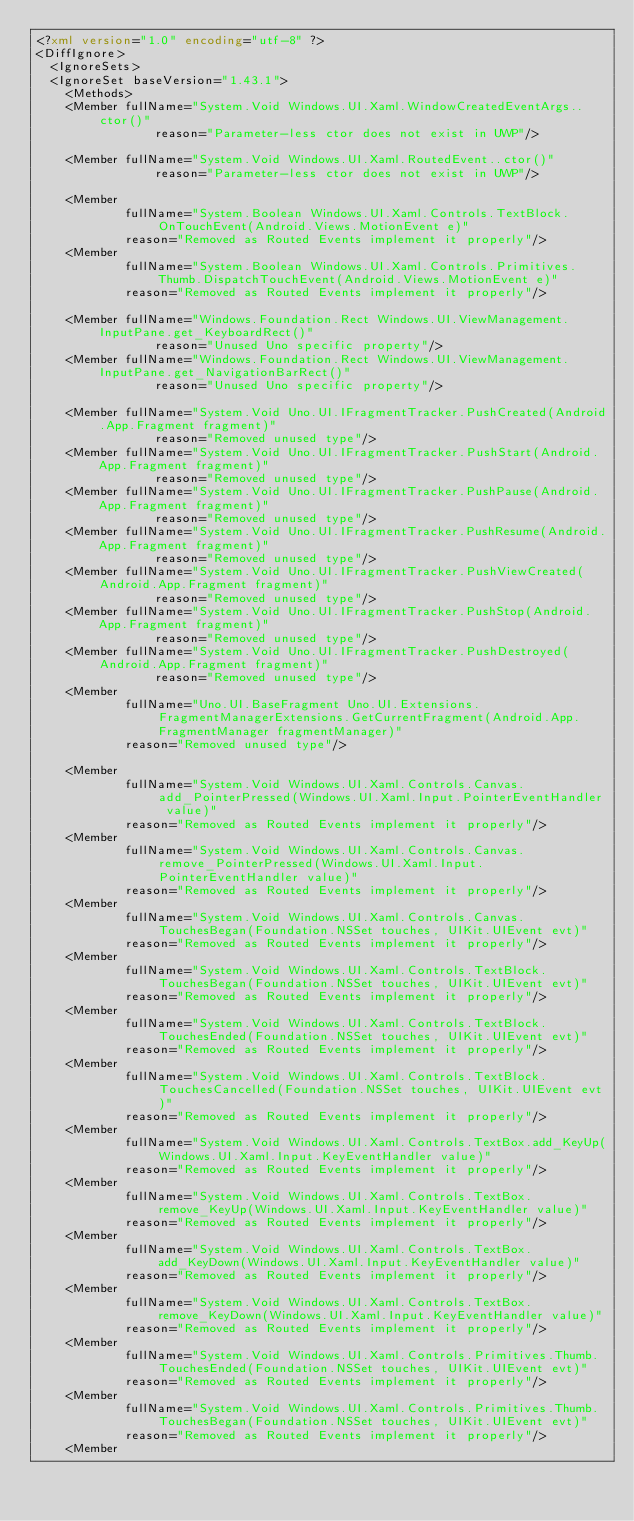<code> <loc_0><loc_0><loc_500><loc_500><_XML_><?xml version="1.0" encoding="utf-8" ?>
<DiffIgnore>
  <IgnoreSets>
	<IgnoreSet baseVersion="1.43.1">
	  <Methods>
		<Member fullName="System.Void Windows.UI.Xaml.WindowCreatedEventArgs..ctor()"
                reason="Parameter-less ctor does not exist in UWP"/>

		<Member fullName="System.Void Windows.UI.Xaml.RoutedEvent..ctor()"
                reason="Parameter-less ctor does not exist in UWP"/>

		<Member
            fullName="System.Boolean Windows.UI.Xaml.Controls.TextBlock.OnTouchEvent(Android.Views.MotionEvent e)"
            reason="Removed as Routed Events implement it properly"/>
		<Member
            fullName="System.Boolean Windows.UI.Xaml.Controls.Primitives.Thumb.DispatchTouchEvent(Android.Views.MotionEvent e)"
            reason="Removed as Routed Events implement it properly"/>

		<Member fullName="Windows.Foundation.Rect Windows.UI.ViewManagement.InputPane.get_KeyboardRect()"
                reason="Unused Uno specific property"/>
		<Member fullName="Windows.Foundation.Rect Windows.UI.ViewManagement.InputPane.get_NavigationBarRect()"
                reason="Unused Uno specific property"/>

		<Member fullName="System.Void Uno.UI.IFragmentTracker.PushCreated(Android.App.Fragment fragment)"
                reason="Removed unused type"/>
		<Member fullName="System.Void Uno.UI.IFragmentTracker.PushStart(Android.App.Fragment fragment)"
                reason="Removed unused type"/>
		<Member fullName="System.Void Uno.UI.IFragmentTracker.PushPause(Android.App.Fragment fragment)"
                reason="Removed unused type"/>
		<Member fullName="System.Void Uno.UI.IFragmentTracker.PushResume(Android.App.Fragment fragment)"
                reason="Removed unused type"/>
		<Member fullName="System.Void Uno.UI.IFragmentTracker.PushViewCreated(Android.App.Fragment fragment)"
                reason="Removed unused type"/>
		<Member fullName="System.Void Uno.UI.IFragmentTracker.PushStop(Android.App.Fragment fragment)"
                reason="Removed unused type"/>
		<Member fullName="System.Void Uno.UI.IFragmentTracker.PushDestroyed(Android.App.Fragment fragment)"
                reason="Removed unused type"/>
		<Member
            fullName="Uno.UI.BaseFragment Uno.UI.Extensions.FragmentManagerExtensions.GetCurrentFragment(Android.App.FragmentManager fragmentManager)"
            reason="Removed unused type"/>

		<Member
            fullName="System.Void Windows.UI.Xaml.Controls.Canvas.add_PointerPressed(Windows.UI.Xaml.Input.PointerEventHandler value)"
            reason="Removed as Routed Events implement it properly"/>
		<Member
            fullName="System.Void Windows.UI.Xaml.Controls.Canvas.remove_PointerPressed(Windows.UI.Xaml.Input.PointerEventHandler value)"
            reason="Removed as Routed Events implement it properly"/>
		<Member
            fullName="System.Void Windows.UI.Xaml.Controls.Canvas.TouchesBegan(Foundation.NSSet touches, UIKit.UIEvent evt)"
            reason="Removed as Routed Events implement it properly"/>
		<Member
            fullName="System.Void Windows.UI.Xaml.Controls.TextBlock.TouchesBegan(Foundation.NSSet touches, UIKit.UIEvent evt)"
            reason="Removed as Routed Events implement it properly"/>
		<Member
            fullName="System.Void Windows.UI.Xaml.Controls.TextBlock.TouchesEnded(Foundation.NSSet touches, UIKit.UIEvent evt)"
            reason="Removed as Routed Events implement it properly"/>
		<Member
            fullName="System.Void Windows.UI.Xaml.Controls.TextBlock.TouchesCancelled(Foundation.NSSet touches, UIKit.UIEvent evt)"
            reason="Removed as Routed Events implement it properly"/>
		<Member
            fullName="System.Void Windows.UI.Xaml.Controls.TextBox.add_KeyUp(Windows.UI.Xaml.Input.KeyEventHandler value)"
            reason="Removed as Routed Events implement it properly"/>
		<Member
            fullName="System.Void Windows.UI.Xaml.Controls.TextBox.remove_KeyUp(Windows.UI.Xaml.Input.KeyEventHandler value)"
            reason="Removed as Routed Events implement it properly"/>
		<Member
            fullName="System.Void Windows.UI.Xaml.Controls.TextBox.add_KeyDown(Windows.UI.Xaml.Input.KeyEventHandler value)"
            reason="Removed as Routed Events implement it properly"/>
		<Member
            fullName="System.Void Windows.UI.Xaml.Controls.TextBox.remove_KeyDown(Windows.UI.Xaml.Input.KeyEventHandler value)"
            reason="Removed as Routed Events implement it properly"/>
		<Member
            fullName="System.Void Windows.UI.Xaml.Controls.Primitives.Thumb.TouchesEnded(Foundation.NSSet touches, UIKit.UIEvent evt)"
            reason="Removed as Routed Events implement it properly"/>
		<Member
            fullName="System.Void Windows.UI.Xaml.Controls.Primitives.Thumb.TouchesBegan(Foundation.NSSet touches, UIKit.UIEvent evt)"
            reason="Removed as Routed Events implement it properly"/>
		<Member</code> 